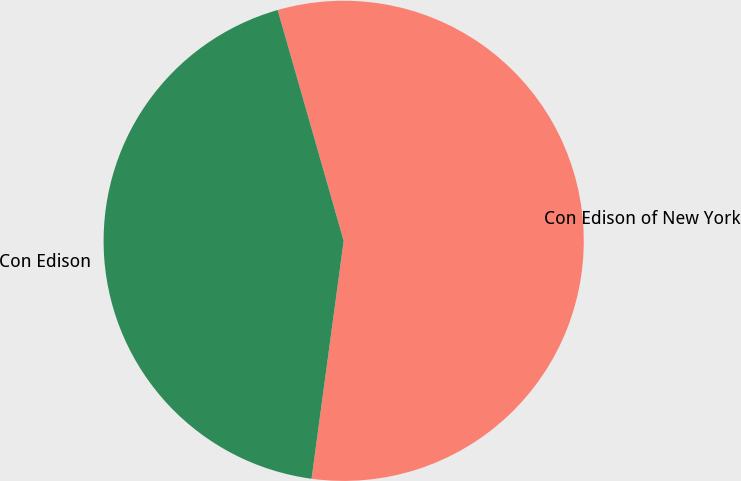Convert chart to OTSL. <chart><loc_0><loc_0><loc_500><loc_500><pie_chart><ecel><fcel>Con Edison of New York<fcel>Con Edison<nl><fcel>0.0%<fcel>56.57%<fcel>43.43%<nl></chart> 